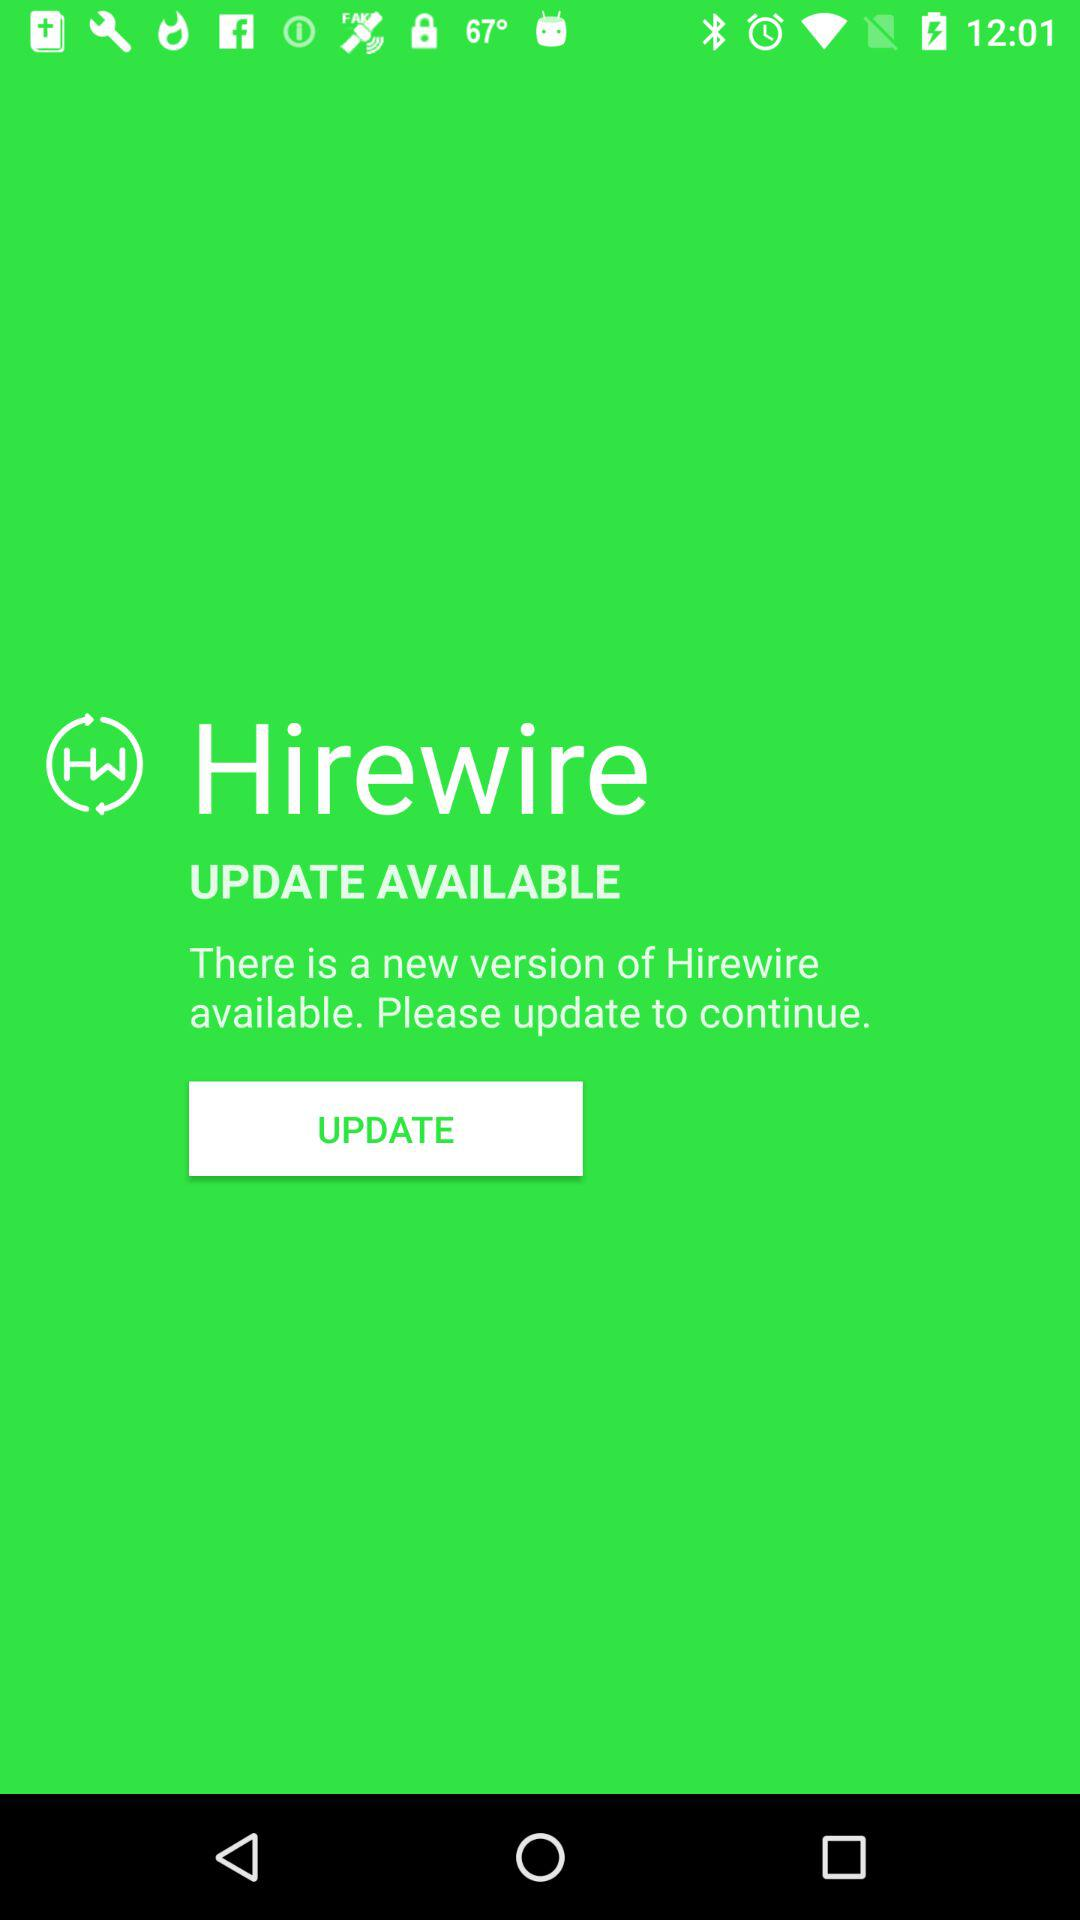What is the name of the application? The name of the application is "Hirewire". 